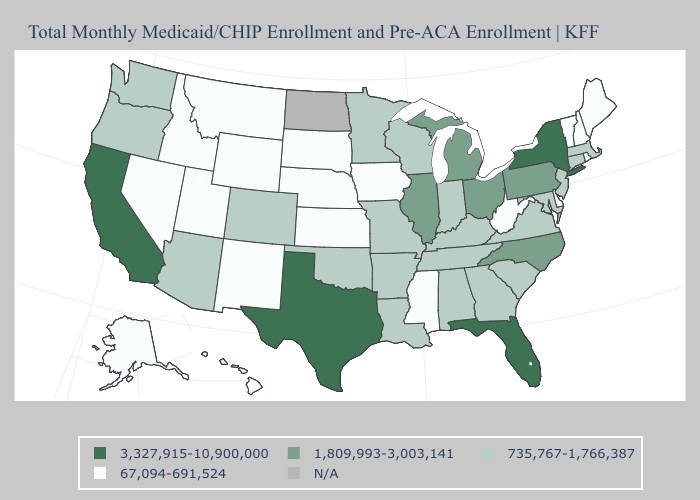Does the map have missing data?
Quick response, please. Yes. Name the states that have a value in the range 67,094-691,524?
Give a very brief answer. Alaska, Delaware, Hawaii, Idaho, Iowa, Kansas, Maine, Mississippi, Montana, Nebraska, Nevada, New Hampshire, New Mexico, Rhode Island, South Dakota, Utah, Vermont, West Virginia, Wyoming. What is the highest value in the USA?
Give a very brief answer. 3,327,915-10,900,000. Which states have the lowest value in the USA?
Quick response, please. Alaska, Delaware, Hawaii, Idaho, Iowa, Kansas, Maine, Mississippi, Montana, Nebraska, Nevada, New Hampshire, New Mexico, Rhode Island, South Dakota, Utah, Vermont, West Virginia, Wyoming. Which states have the highest value in the USA?
Keep it brief. California, Florida, New York, Texas. Name the states that have a value in the range 3,327,915-10,900,000?
Keep it brief. California, Florida, New York, Texas. What is the value of West Virginia?
Give a very brief answer. 67,094-691,524. Name the states that have a value in the range N/A?
Quick response, please. North Dakota. Is the legend a continuous bar?
Concise answer only. No. What is the value of Oklahoma?
Quick response, please. 735,767-1,766,387. Name the states that have a value in the range 3,327,915-10,900,000?
Write a very short answer. California, Florida, New York, Texas. What is the lowest value in states that border New York?
Give a very brief answer. 67,094-691,524. What is the highest value in the USA?
Short answer required. 3,327,915-10,900,000. What is the lowest value in the MidWest?
Quick response, please. 67,094-691,524. 